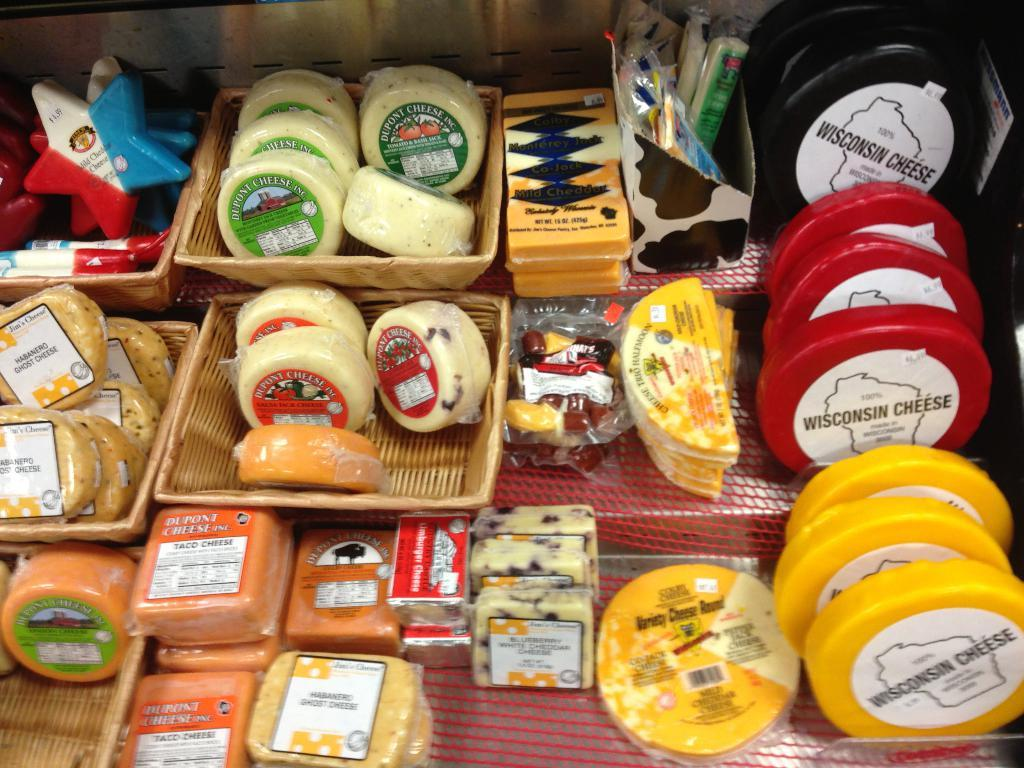<image>
Relay a brief, clear account of the picture shown. lots of cheese on display including Wisconsin Cheese and Dupont Cheese 